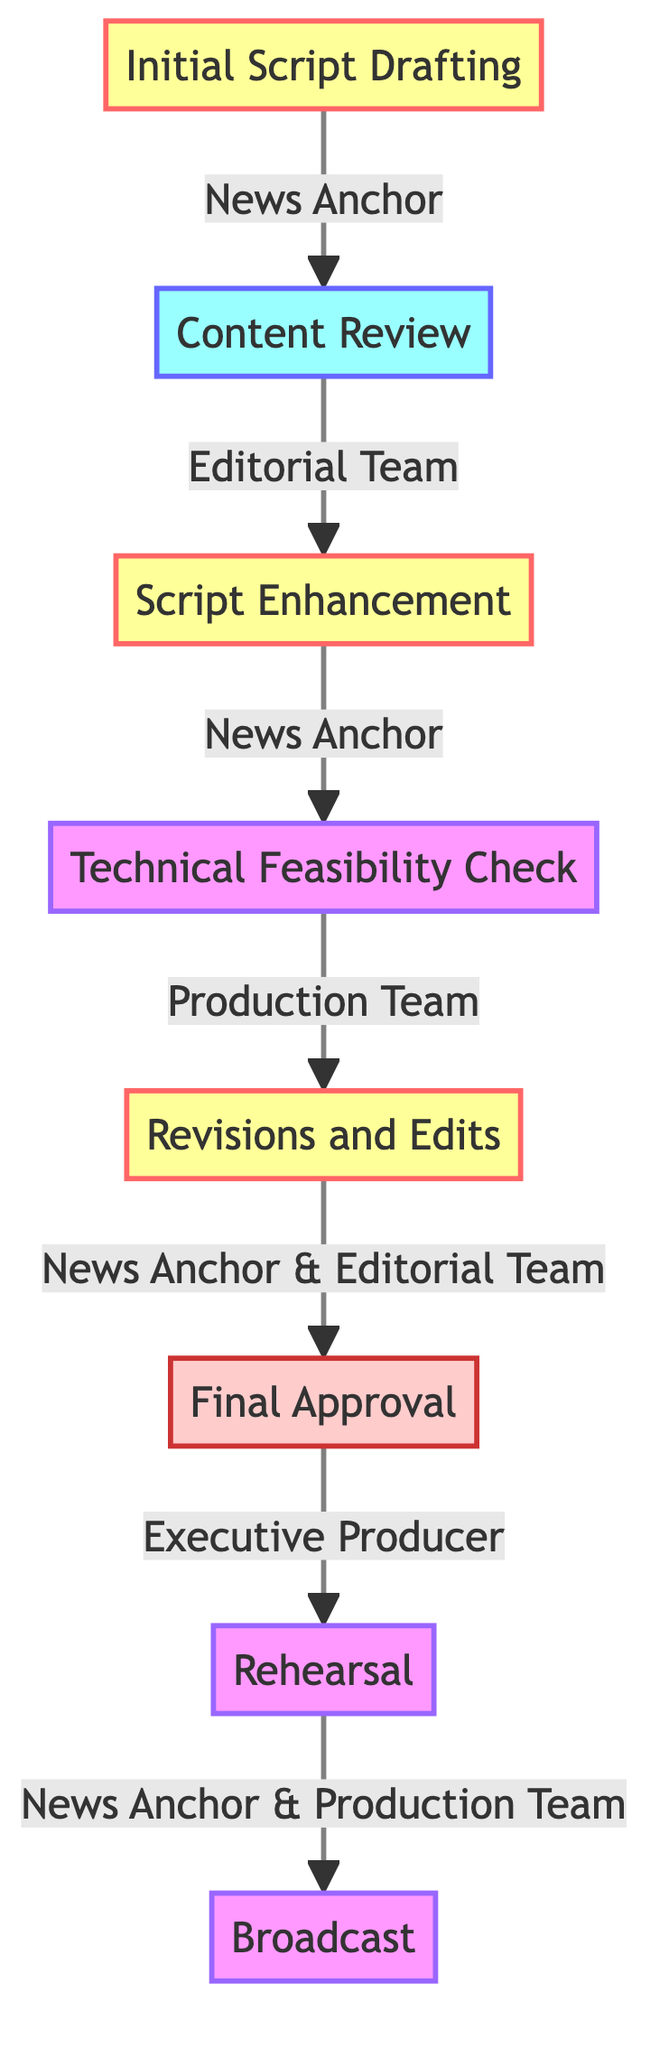What is the first stage in the collaboration process? The first stage in the collaboration process is "Initial Script Drafting," as indicated at the start of the flow chart.
Answer: Initial Script Drafting Who is responsible for the "Technical Feasibility Check"? The "Technical Feasibility Check" is assigned to the "Production Team," which is clearly labeled in the diagram next to that stage.
Answer: Production Team How many stages are involved in this flow chart? By counting the nodes in the diagram, there are a total of eight stages involved in the collaboration process.
Answer: Eight What follows the "Final Approval" stage? The stage that follows "Final Approval" is "Rehearsal," as shown in the flow from one node to the next in the diagram.
Answer: Rehearsal Which two parties are responsible for "Revisions and Edits"? "Revisions and Edits" involve both the "News Anchor" and the "Editorial Team," as indicated in the responsible party section for that stage in the flow chart.
Answer: News Anchor and Editorial Team What is the last stage in the described process? The last stage in this process is "Broadcast," marked as the final node in the flow chart that represents the culmination of all previous stages.
Answer: Broadcast How does the "Content Review" lead to the next stage? "Content Review" leads to "Script Enhancement" by connecting them directly with an arrow, indicating that the review is a prerequisite for enhancing the script.
Answer: Script Enhancement Which stage is overseen by the Executive Producer? The Executive Producer is responsible for the "Final Approval" stage, as noted in the diagram's description for that particular stage.
Answer: Final Approval What is the primary goal of the "Rehearsal" stage? The primary goal of the "Rehearsal" stage is to ensure smooth delivery and timing during the broadcast, which is summarized in the description of that stage.
Answer: Smooth delivery and timing 